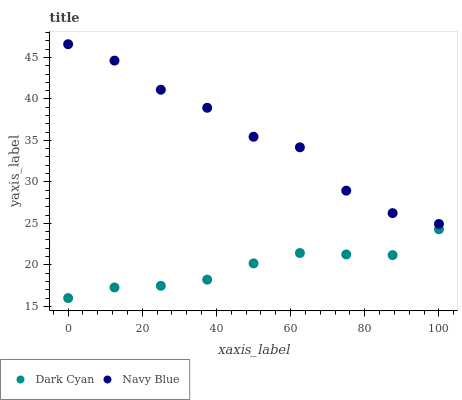Does Dark Cyan have the minimum area under the curve?
Answer yes or no. Yes. Does Navy Blue have the maximum area under the curve?
Answer yes or no. Yes. Does Navy Blue have the minimum area under the curve?
Answer yes or no. No. Is Dark Cyan the smoothest?
Answer yes or no. Yes. Is Navy Blue the roughest?
Answer yes or no. Yes. Is Navy Blue the smoothest?
Answer yes or no. No. Does Dark Cyan have the lowest value?
Answer yes or no. Yes. Does Navy Blue have the lowest value?
Answer yes or no. No. Does Navy Blue have the highest value?
Answer yes or no. Yes. Is Dark Cyan less than Navy Blue?
Answer yes or no. Yes. Is Navy Blue greater than Dark Cyan?
Answer yes or no. Yes. Does Dark Cyan intersect Navy Blue?
Answer yes or no. No. 